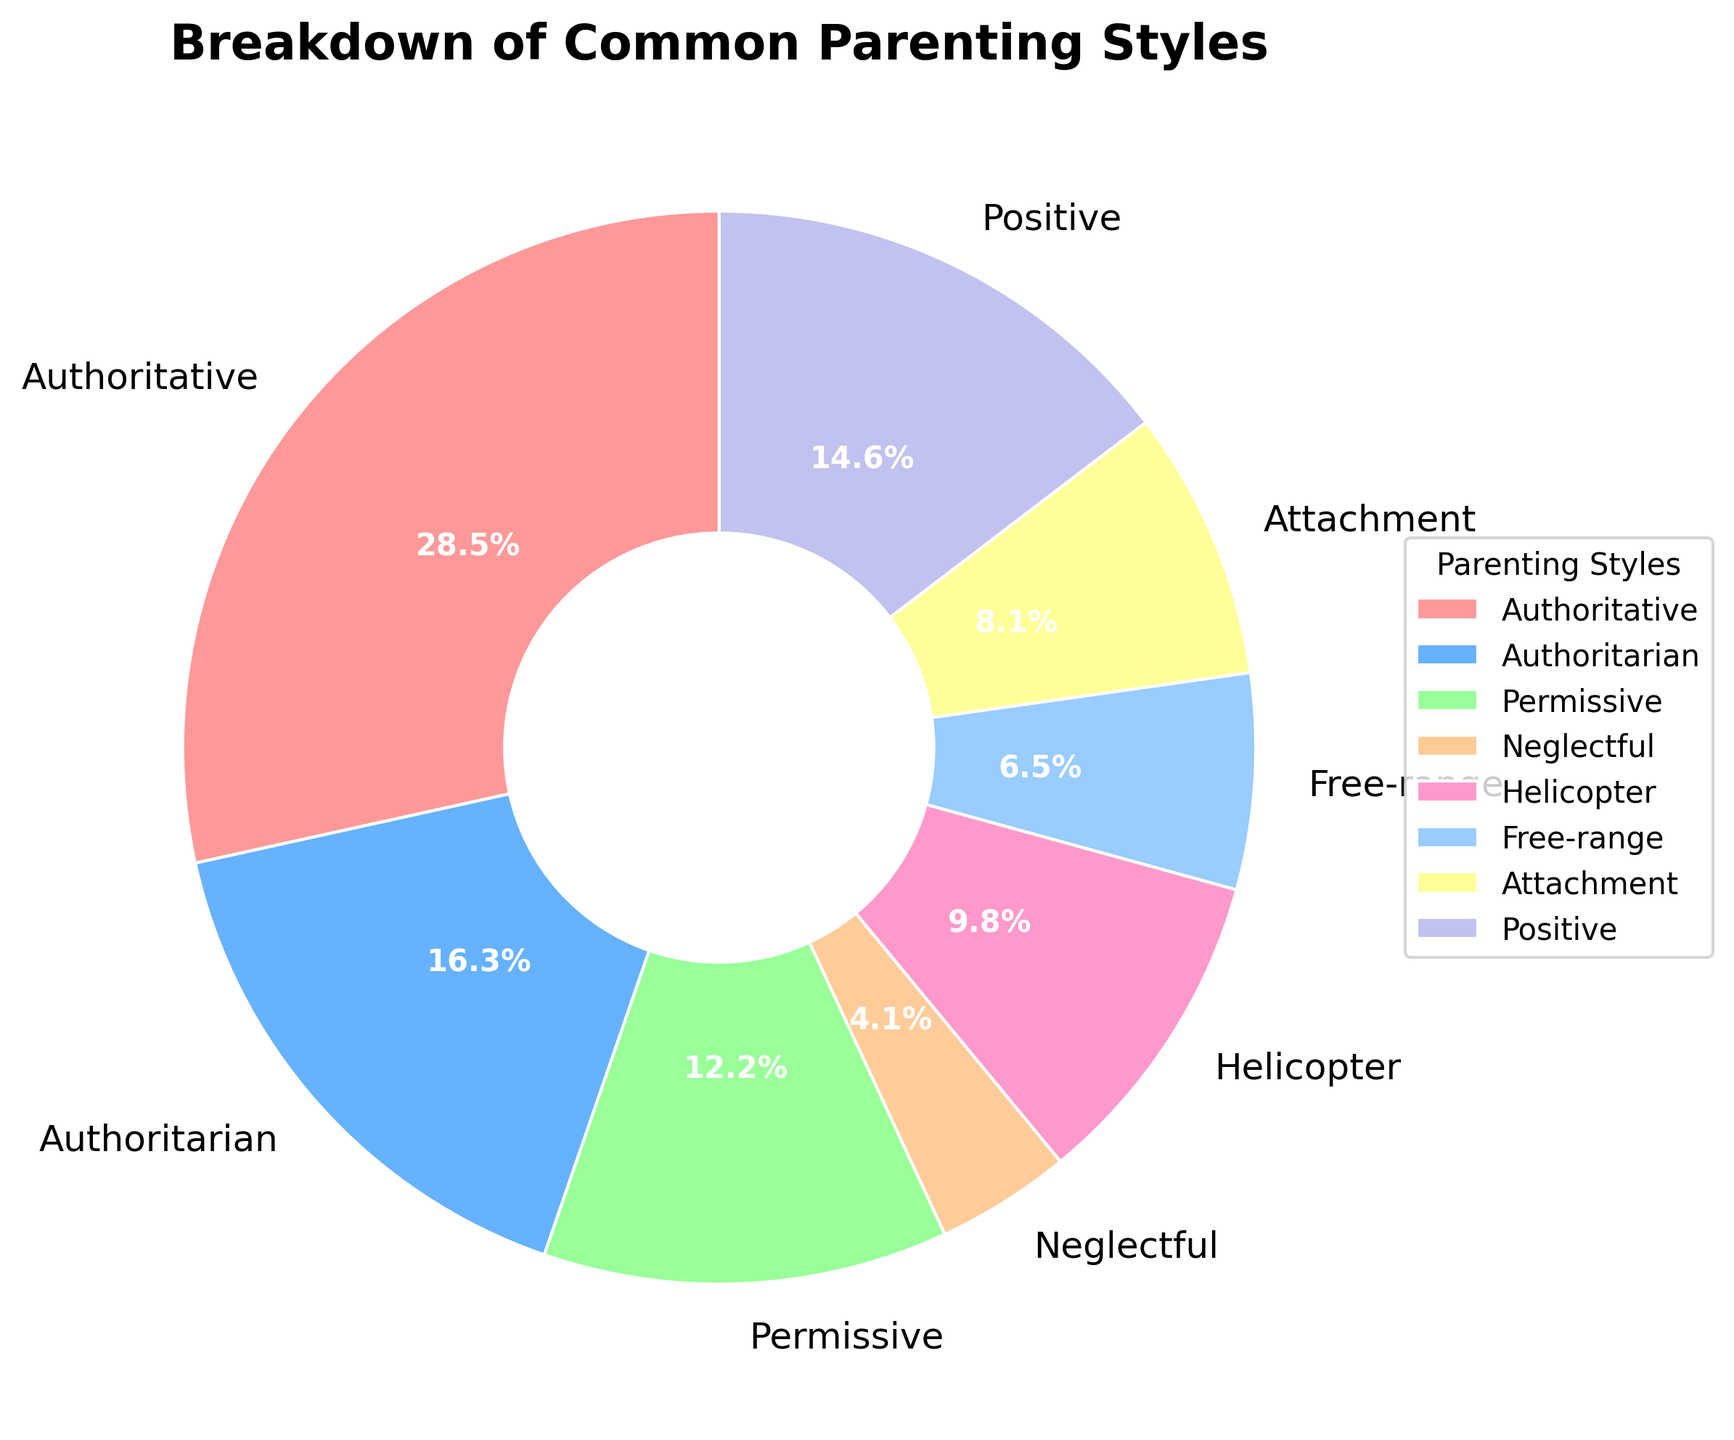Which parenting style has the highest prevalence among guardians? To find the answer, look at the segment of the pie chart with the largest size. The label associated with this segment indicates the parenting style with the highest prevalence. The largest segment is for "Authoritative" style.
Answer: Authoritative What is the combined percentage for Helicopter and Free-range parenting styles? Identify the percentages for Helicopter and Free-range styles from the chart. Helicopter is 12% and Free-range is 8%. Add them up: 12 + 8 = 20%
Answer: 20% Which parenting style has a lower prevalence: Permissive or Positive? Compare the percentages for Permissive and Positive styles. Permissive is 15% and Positive is 18%. Permissive has a lower prevalence.
Answer: Permissive What is the difference in percentage between Authoritative and Authoritarian parenting styles? Find the percentages for Authoritative and Authoritarian styles from the chart (35% for Authoritative and 20% for Authoritarian). Subtract the smaller from the larger: 35 - 20 = 15%
Answer: 15% Which group is represented by the light blue segment in the pie chart? Locate the segment with light blue color and check the associated label. The light blue segment corresponds to "Free-range".
Answer: Free-range How many parenting styles have a percentage greater than 15%? Check each segment's percentage and count those greater than 15%. Authoritative (35%), Authoritarian (20%), and Positive (18%) are the only ones. There are three such segments.
Answer: 3 What is the average prevalence percentage of Permissive, Neglectful, and Attachment parenting styles? Find the percentages for Permissive (15%), Neglectful (5%), and Attachment (10%). Add them up and divide by the number of styles: (15 + 5 + 10)/3 = 30/3 = 10%
Answer: 10% Which style has greater representation, Permissive or Helicopter? Compare the percentages for Permissive (15%) and Helicopter (12%). Permissive is higher.
Answer: Permissive What is the total percentage for all parenting styles combined that have a prevalence below 10%? Identify the styles with percentages below 10% (Neglectful at 5%, Free-range at 8%). Add them up: 5 + 8 = 13%
Answer: 13% 